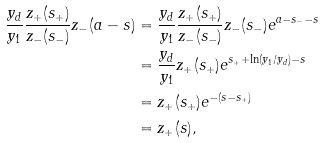Convert formula to latex. <formula><loc_0><loc_0><loc_500><loc_500>\frac { y _ { d } } { y _ { 1 } } \frac { z _ { + } ( s _ { + } ) } { z _ { - } ( s _ { - } ) } z _ { - } ( a - s ) & = \frac { y _ { d } } { y _ { 1 } } \frac { z _ { + } ( s _ { + } ) } { z _ { - } ( s _ { - } ) } z _ { - } ( s _ { - } ) e ^ { a - s _ { - } - s } \\ & = \frac { y _ { d } } { y _ { 1 } } z _ { + } ( s _ { + } ) e ^ { s _ { + } + \ln ( y _ { 1 } / y _ { d } ) - s } \\ & = z _ { + } ( s _ { + } ) e ^ { - ( s - s _ { + } ) } \\ & = z _ { + } ( s ) ,</formula> 